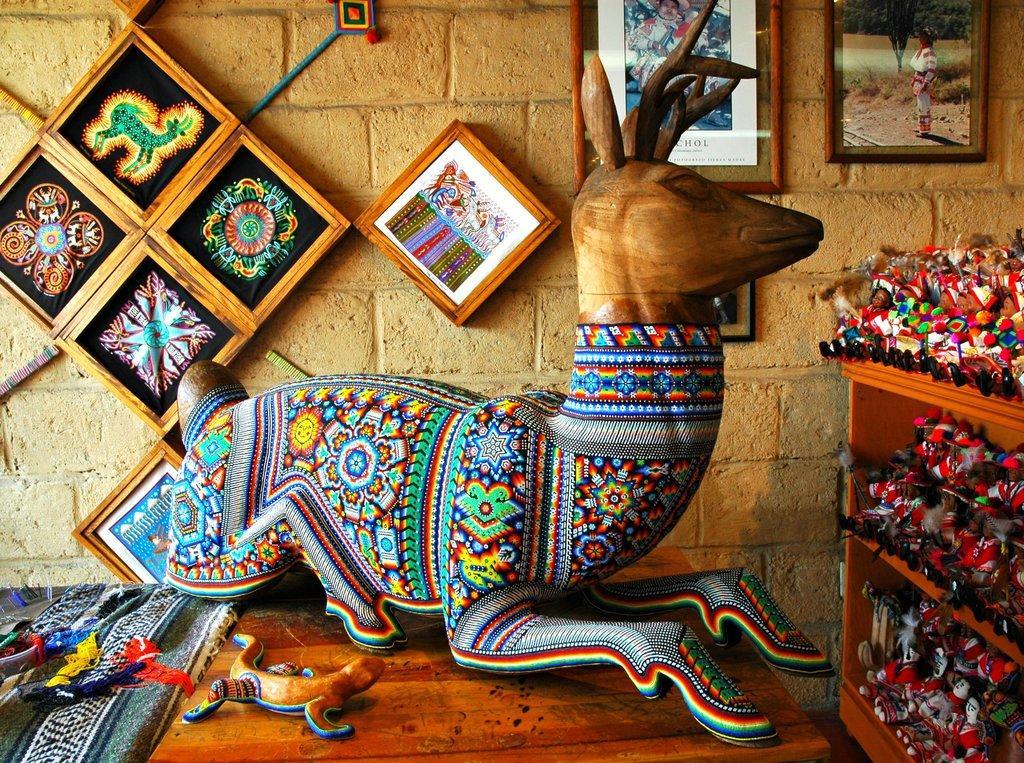How would you summarize this image in a sentence or two? In this image I can see a wooden statue of an animal which is brown in color and I can see it is painted with different colors on the brown colored surface. I can see few other wooden objects on the surface. In the background I can see a rack with number of toys in it, the brown colored wall and few photo frames attached to the wall. 